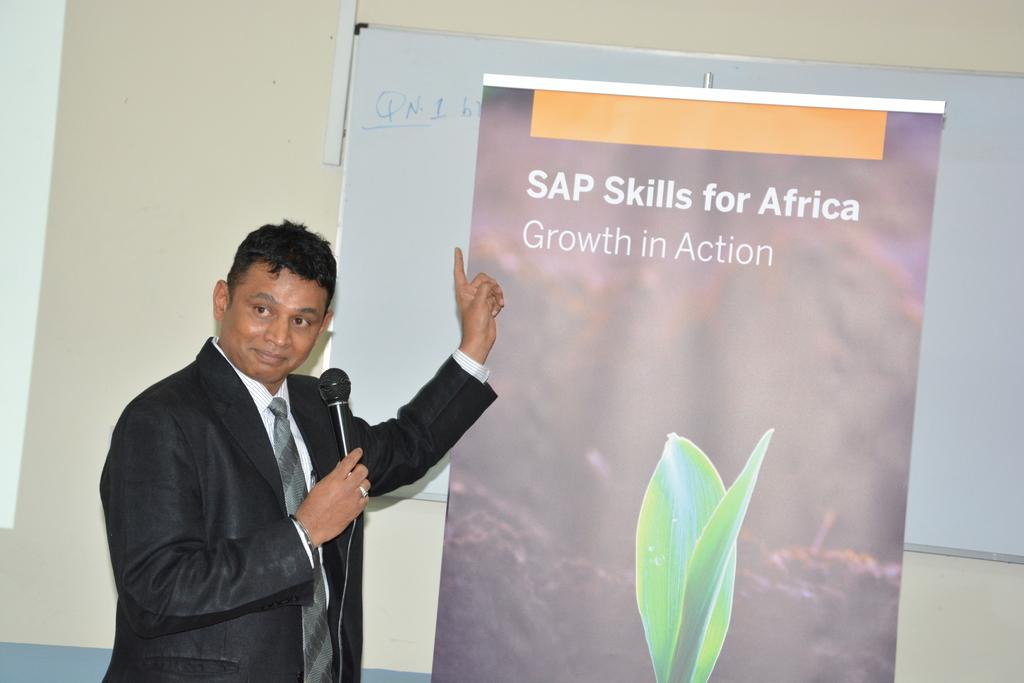What is the person in the image holding? The person is holding a microphone in the image. What can be seen on the board in the image? There is written text on a board in the image. What type of structure is visible in the image? There is a wall visible in the image. How many women are reading a book in the image? There are no women or books present in the image. 